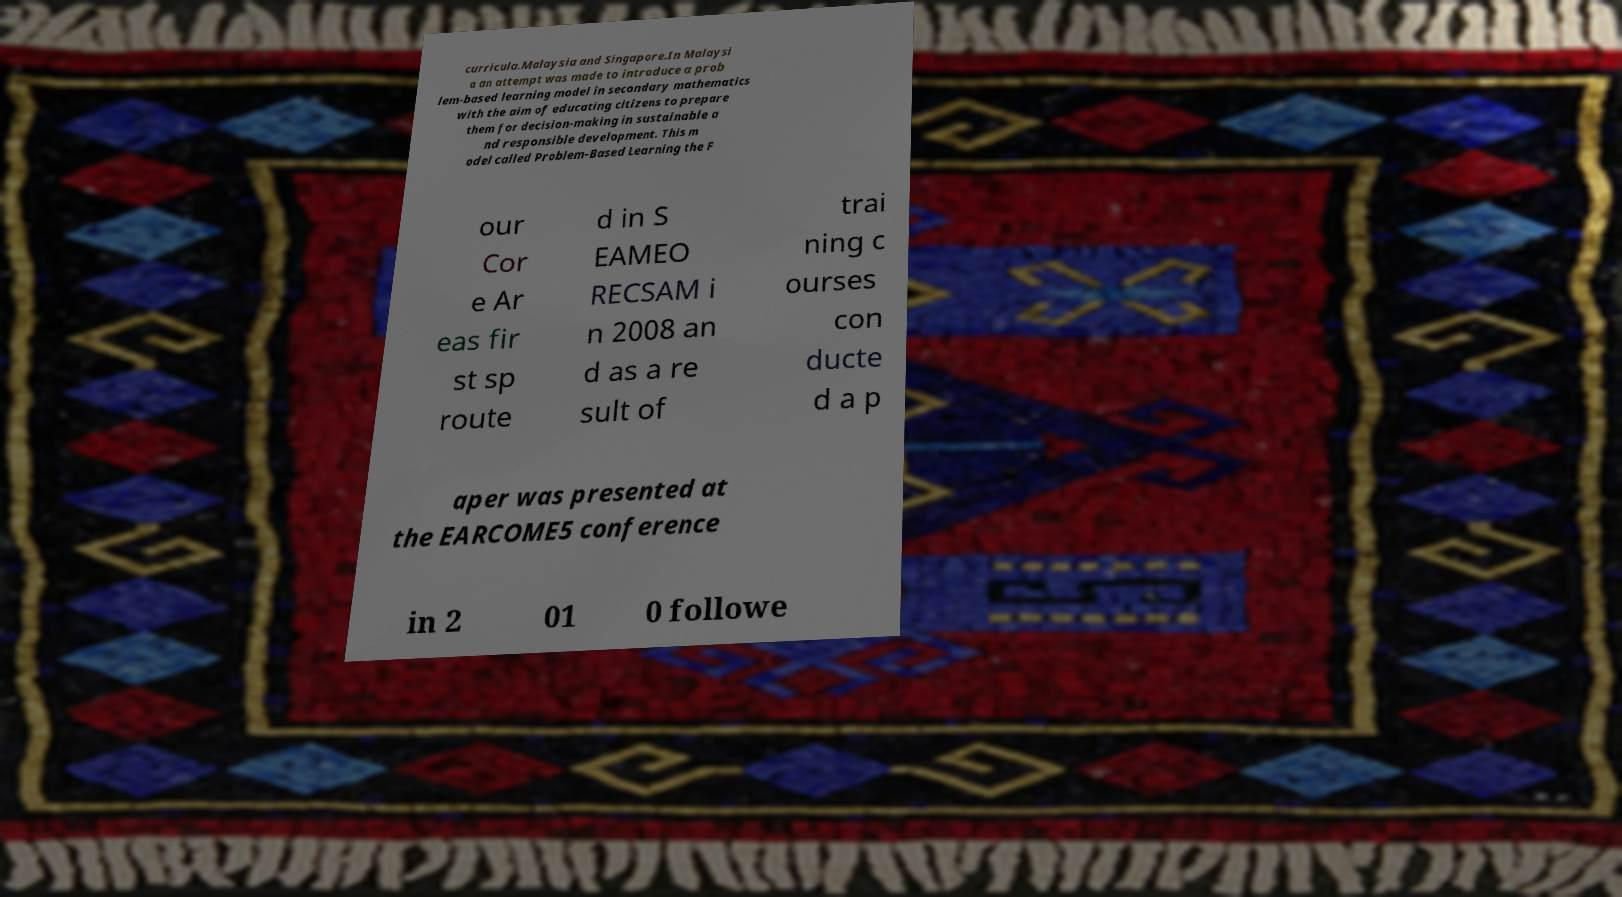Could you assist in decoding the text presented in this image and type it out clearly? curricula.Malaysia and Singapore.In Malaysi a an attempt was made to introduce a prob lem-based learning model in secondary mathematics with the aim of educating citizens to prepare them for decision-making in sustainable a nd responsible development. This m odel called Problem-Based Learning the F our Cor e Ar eas fir st sp route d in S EAMEO RECSAM i n 2008 an d as a re sult of trai ning c ourses con ducte d a p aper was presented at the EARCOME5 conference in 2 01 0 followe 